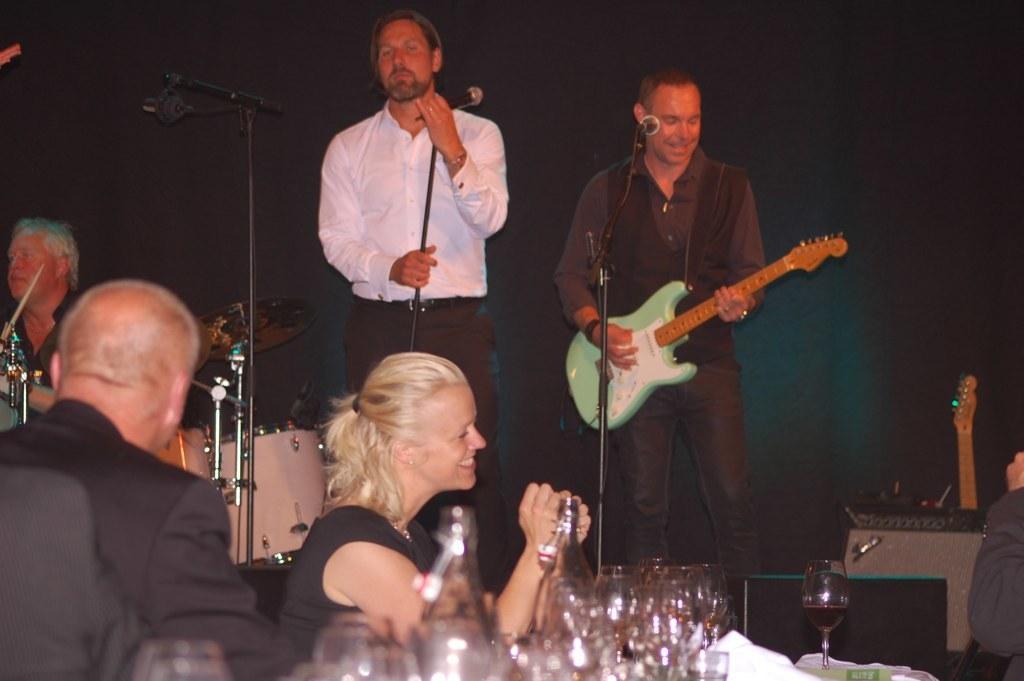Could you give a brief overview of what you see in this image? Background is dark. We can see a person standing in front of mike. This man is playing a guitar. We can see a woman and a man here. We can see bottles and glasses. This is an electronic device. Here we can see cymbal and beside to it there is a man. 